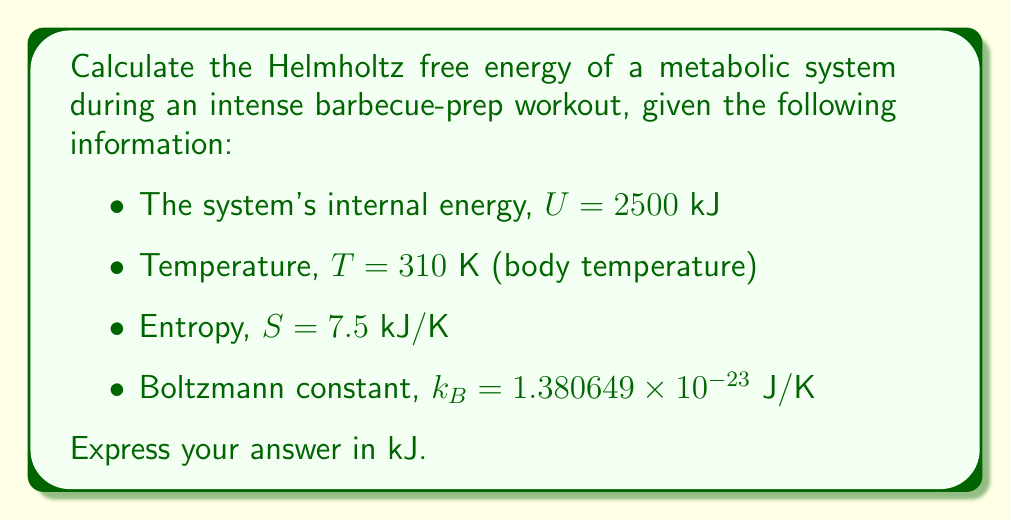What is the answer to this math problem? To solve this problem, we'll use the definition of Helmholtz free energy and the given information. Let's proceed step-by-step:

1) The Helmholtz free energy ($F$) is defined as:

   $$F = U - TS$$

   where $U$ is the internal energy, $T$ is the temperature, and $S$ is the entropy.

2) We're given:
   - $U = 2500$ kJ
   - $T = 310$ K
   - $S = 7.5$ kJ/K

3) Let's substitute these values into the equation:

   $$F = 2500 \text{ kJ} - (310 \text{ K})(7.5 \text{ kJ/K})$$

4) First, let's calculate the $TS$ term:
   
   $$TS = 310 \times 7.5 = 2325 \text{ kJ}$$

5) Now, we can subtract this from $U$:

   $$F = 2500 \text{ kJ} - 2325 \text{ kJ} = 175 \text{ kJ}$$

Therefore, the Helmholtz free energy of the metabolic system during the intense barbecue-prep workout is 175 kJ.
Answer: 175 kJ 